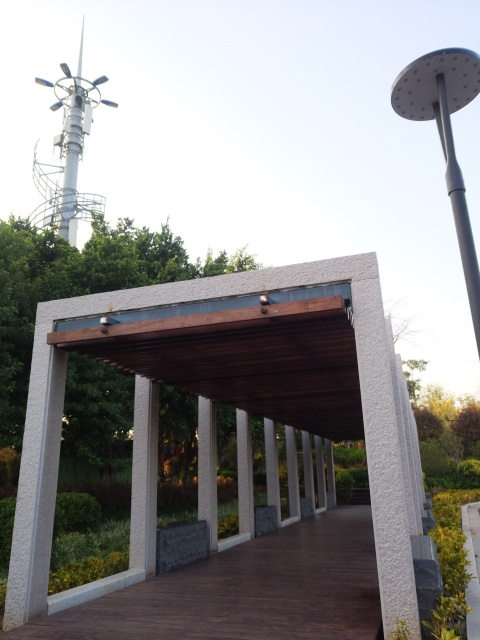What time of day does this image seem to depict? The long shadows and the warm light suggest that this photo was taken in the late afternoon, possibly during the golden hour prior to sunset, which is known for its soft, diffused light and is a favorite among photographers for its aesthetic qualities. 